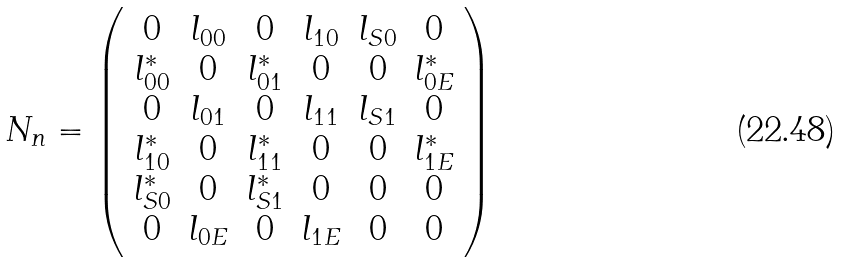Convert formula to latex. <formula><loc_0><loc_0><loc_500><loc_500>N _ { n } = \left ( \begin{array} { c c c c c c } 0 & l _ { 0 0 } & 0 & l _ { 1 0 } & l _ { S 0 } & 0 \\ l _ { 0 0 } ^ { \ast } & 0 & l _ { 0 1 } ^ { \ast } & 0 & 0 & l _ { 0 E } ^ { \ast } \\ 0 & l _ { 0 1 } & 0 & l _ { 1 1 } & l _ { S 1 } & 0 \\ l _ { 1 0 } ^ { \ast } & 0 & l _ { 1 1 } ^ { \ast } & 0 & 0 & l _ { 1 E } ^ { \ast } \\ l _ { S 0 } ^ { \ast } & 0 & l _ { S 1 } ^ { \ast } & 0 & 0 & 0 \\ 0 & l _ { 0 E } & 0 & l _ { 1 E } & 0 & 0 \end{array} \right )</formula> 